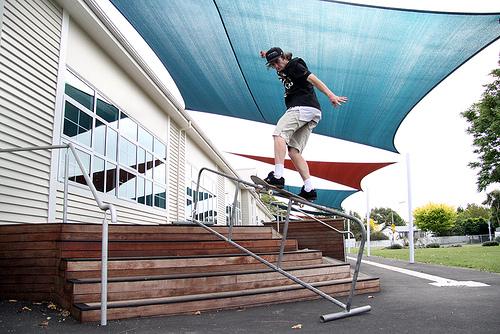How many steps are there?
Short answer required. 5. Is the man traveling?
Short answer required. No. If he moves to the right will he be going up the rail?
Keep it brief. No. Is this an appropriate place to practice this trick?
Concise answer only. No. 